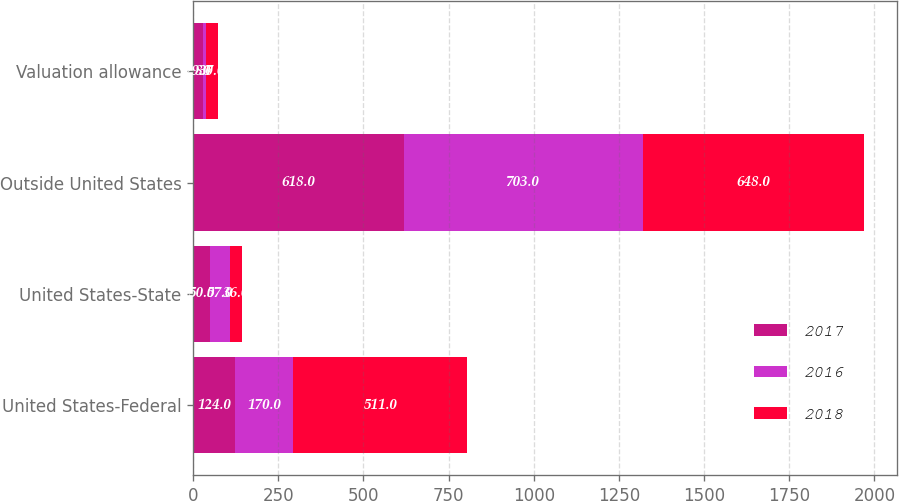Convert chart. <chart><loc_0><loc_0><loc_500><loc_500><stacked_bar_chart><ecel><fcel>United States-Federal<fcel>United States-State<fcel>Outside United States<fcel>Valuation allowance<nl><fcel>2017<fcel>124<fcel>50<fcel>618<fcel>29<nl><fcel>2016<fcel>170<fcel>57<fcel>703<fcel>8<nl><fcel>2018<fcel>511<fcel>36<fcel>648<fcel>37<nl></chart> 